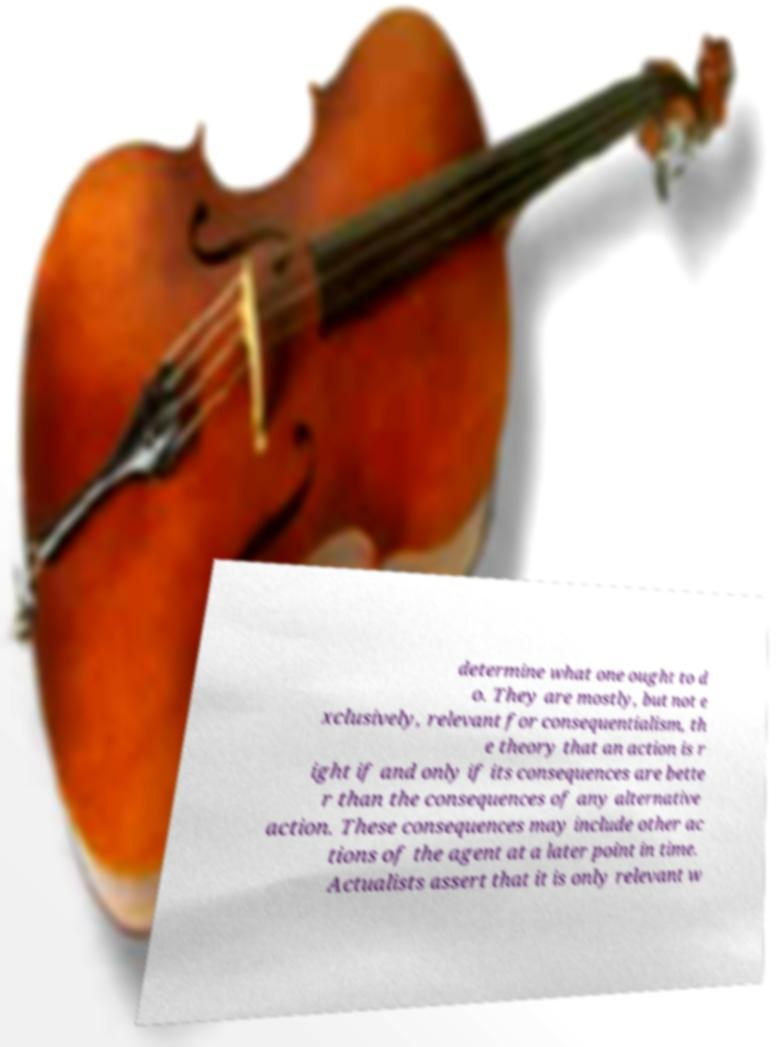Please read and relay the text visible in this image. What does it say? determine what one ought to d o. They are mostly, but not e xclusively, relevant for consequentialism, th e theory that an action is r ight if and only if its consequences are bette r than the consequences of any alternative action. These consequences may include other ac tions of the agent at a later point in time. Actualists assert that it is only relevant w 